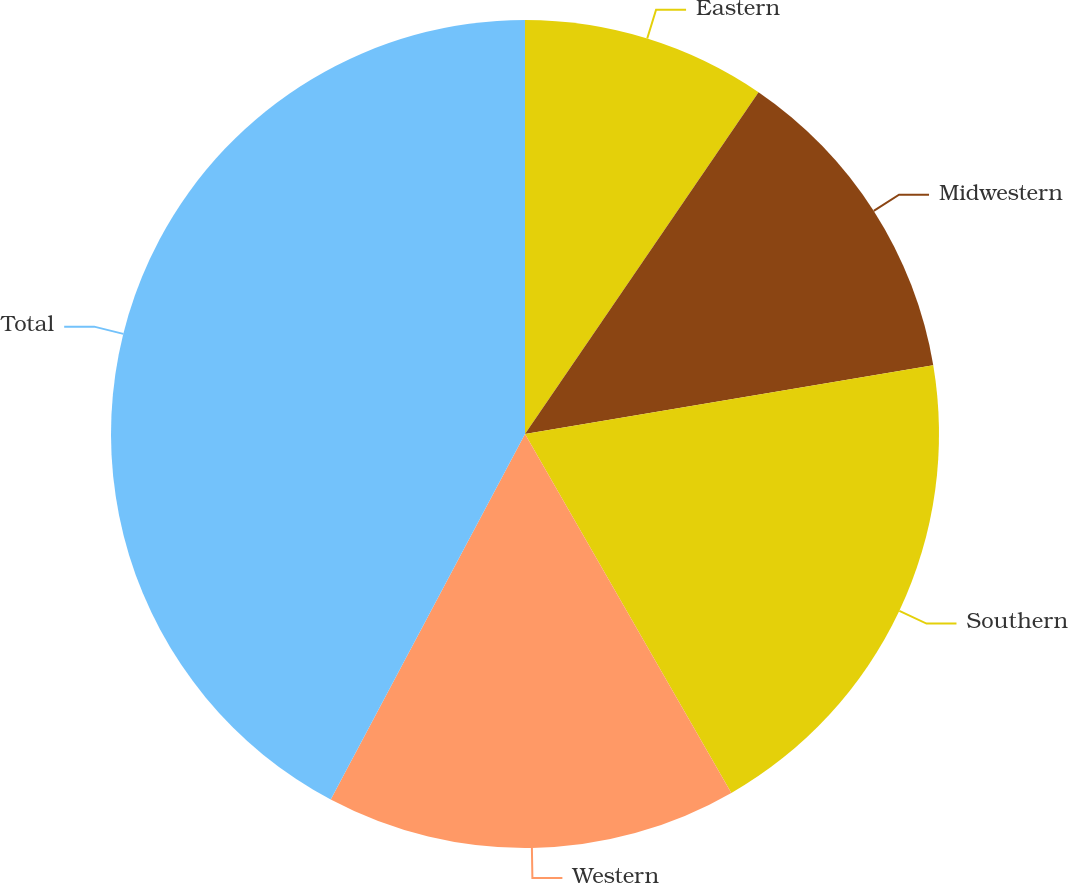Convert chart to OTSL. <chart><loc_0><loc_0><loc_500><loc_500><pie_chart><fcel>Eastern<fcel>Midwestern<fcel>Southern<fcel>Western<fcel>Total<nl><fcel>9.54%<fcel>12.81%<fcel>19.35%<fcel>16.08%<fcel>42.23%<nl></chart> 